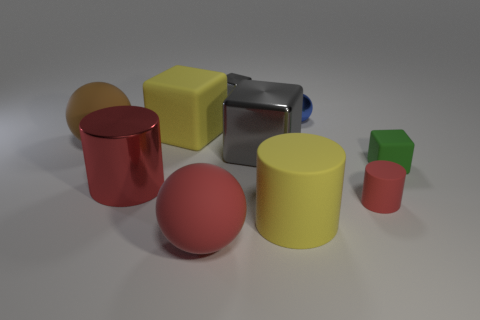What material is the object that is the same color as the large matte cylinder?
Make the answer very short. Rubber. What is the color of the metal cylinder that is the same size as the brown matte object?
Keep it short and to the point. Red. Are there any large rubber things that have the same color as the big matte cylinder?
Your answer should be very brief. Yes. What number of objects are either big yellow things that are in front of the red metal thing or big cylinders?
Ensure brevity in your answer.  2. What number of other things are there of the same size as the blue thing?
Provide a short and direct response. 3. There is a block left of the small object to the left of the yellow matte object that is in front of the large brown object; what is it made of?
Your answer should be very brief. Rubber. What number of spheres are either large cyan matte objects or green rubber objects?
Give a very brief answer. 0. Is the number of cubes that are on the right side of the small gray object greater than the number of small metallic things that are in front of the big gray shiny object?
Ensure brevity in your answer.  Yes. What number of gray shiny cubes are to the right of the red matte object in front of the large yellow cylinder?
Your answer should be compact. 2. How many things are small cyan metal balls or small red matte things?
Keep it short and to the point. 1. 